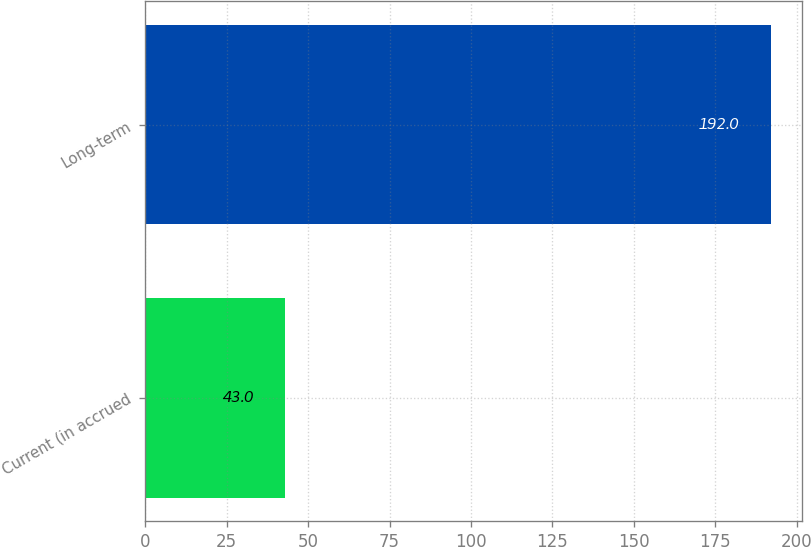Convert chart to OTSL. <chart><loc_0><loc_0><loc_500><loc_500><bar_chart><fcel>Current (in accrued<fcel>Long-term<nl><fcel>43<fcel>192<nl></chart> 